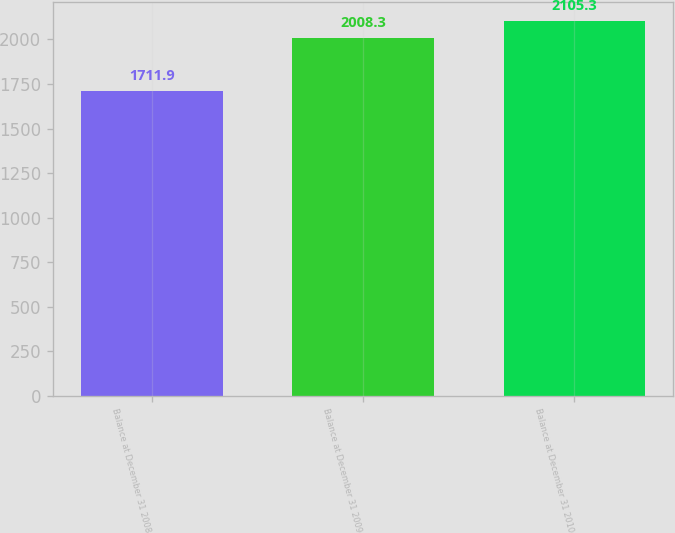Convert chart. <chart><loc_0><loc_0><loc_500><loc_500><bar_chart><fcel>Balance at December 31 2008<fcel>Balance at December 31 2009<fcel>Balance at December 31 2010<nl><fcel>1711.9<fcel>2008.3<fcel>2105.3<nl></chart> 